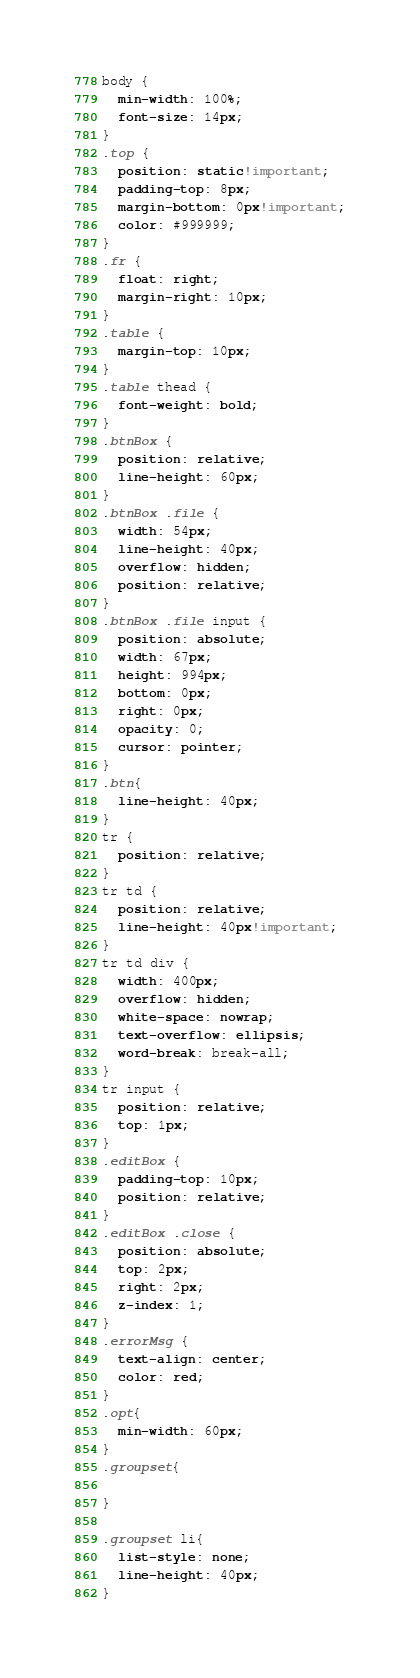<code> <loc_0><loc_0><loc_500><loc_500><_CSS_>body {
  min-width: 100%;
  font-size: 14px;
}
.top {
  position: static!important;
  padding-top: 8px;
  margin-bottom: 0px!important;
  color: #999999;
}
.fr {
  float: right;
  margin-right: 10px;
}
.table {
  margin-top: 10px;
}
.table thead {
  font-weight: bold;
}
.btnBox {
  position: relative;
  line-height: 60px;
}
.btnBox .file {
  width: 54px;
  line-height: 40px;
  overflow: hidden;
  position: relative;
}
.btnBox .file input {
  position: absolute;
  width: 67px;
  height: 994px;
  bottom: 0px;
  right: 0px;
  opacity: 0;
  cursor: pointer;
}
.btn{
  line-height: 40px;
}
tr {
  position: relative;
}
tr td {
  position: relative;
  line-height: 40px!important;
}
tr td div {
  width: 400px;
  overflow: hidden;
  white-space: nowrap;
  text-overflow: ellipsis;
  word-break: break-all;
}
tr input {
  position: relative;
  top: 1px;
}
.editBox {
  padding-top: 10px;
  position: relative;
}
.editBox .close {
  position: absolute;
  top: 2px;
  right: 2px;
  z-index: 1;
}
.errorMsg {
  text-align: center;
  color: red;
}
.opt{
  min-width: 60px;
}
.groupset{

}

.groupset li{
  list-style: none;
  line-height: 40px;
}

</code> 